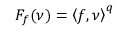Convert formula to latex. <formula><loc_0><loc_0><loc_500><loc_500>F _ { f } ( \nu ) = \left \langle f , \nu \right \rangle ^ { q }</formula> 